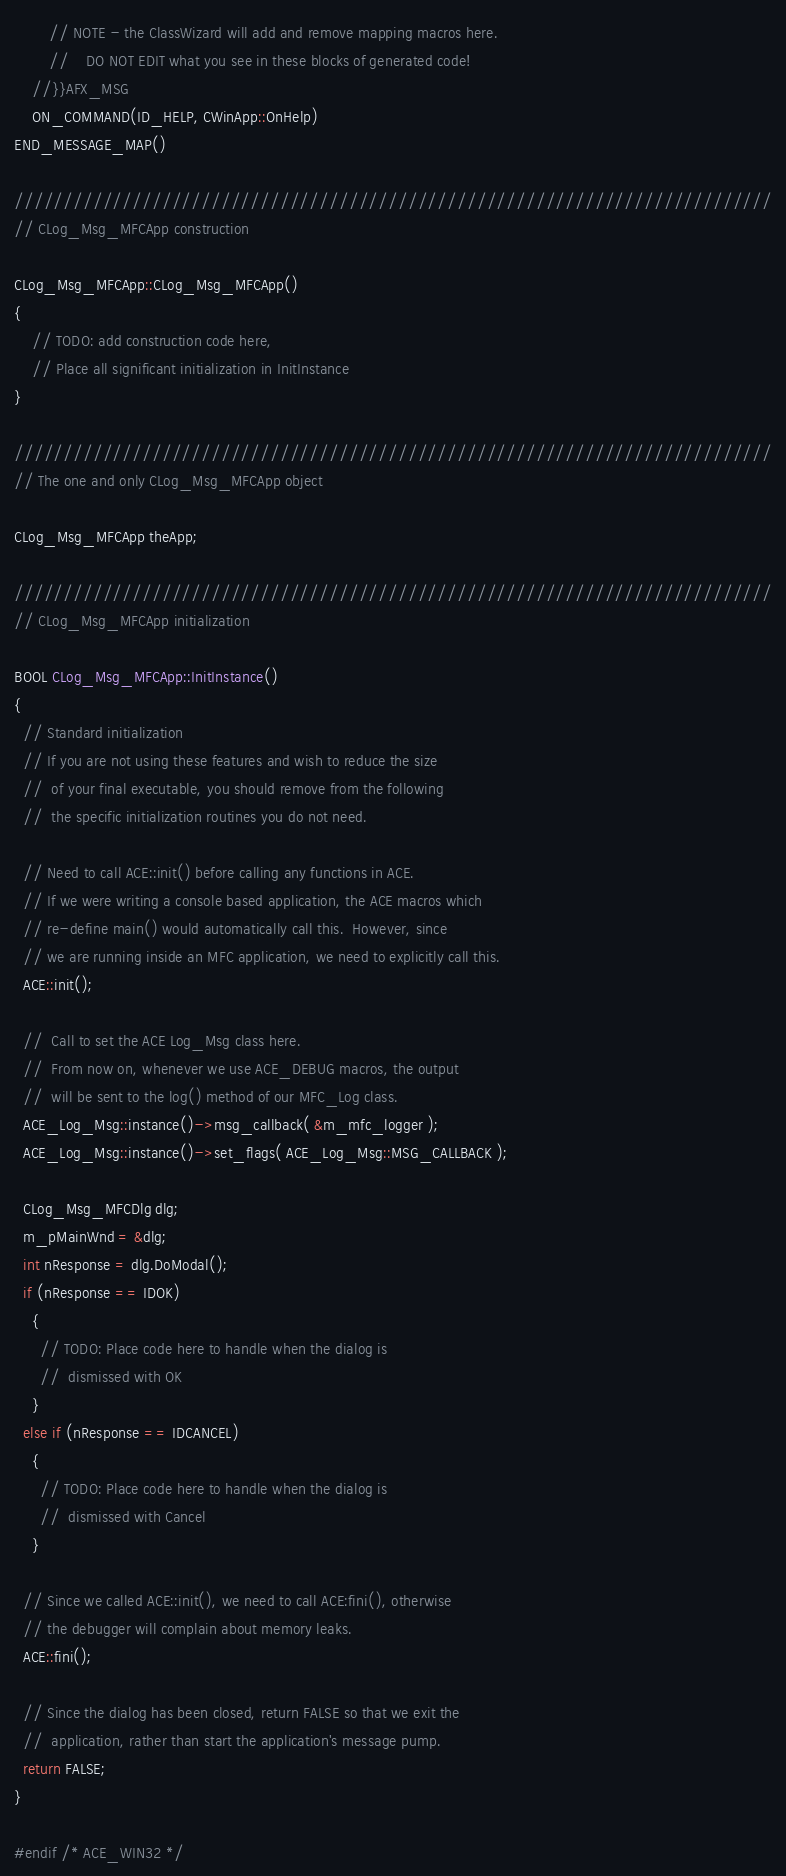<code> <loc_0><loc_0><loc_500><loc_500><_C++_>        // NOTE - the ClassWizard will add and remove mapping macros here.
        //    DO NOT EDIT what you see in these blocks of generated code!
    //}}AFX_MSG
    ON_COMMAND(ID_HELP, CWinApp::OnHelp)
END_MESSAGE_MAP()

/////////////////////////////////////////////////////////////////////////////
// CLog_Msg_MFCApp construction

CLog_Msg_MFCApp::CLog_Msg_MFCApp()
{
    // TODO: add construction code here,
    // Place all significant initialization in InitInstance
}

/////////////////////////////////////////////////////////////////////////////
// The one and only CLog_Msg_MFCApp object

CLog_Msg_MFCApp theApp;

/////////////////////////////////////////////////////////////////////////////
// CLog_Msg_MFCApp initialization

BOOL CLog_Msg_MFCApp::InitInstance()
{
  // Standard initialization
  // If you are not using these features and wish to reduce the size
  //  of your final executable, you should remove from the following
  //  the specific initialization routines you do not need.

  // Need to call ACE::init() before calling any functions in ACE.
  // If we were writing a console based application, the ACE macros which
  // re-define main() would automatically call this.  However, since
  // we are running inside an MFC application, we need to explicitly call this.
  ACE::init();

  //  Call to set the ACE Log_Msg class here.
  //  From now on, whenever we use ACE_DEBUG macros, the output
  //  will be sent to the log() method of our MFC_Log class.
  ACE_Log_Msg::instance()->msg_callback( &m_mfc_logger );
  ACE_Log_Msg::instance()->set_flags( ACE_Log_Msg::MSG_CALLBACK );

  CLog_Msg_MFCDlg dlg;
  m_pMainWnd = &dlg;
  int nResponse = dlg.DoModal();
  if (nResponse == IDOK)
    {
      // TODO: Place code here to handle when the dialog is
      //  dismissed with OK
    }
  else if (nResponse == IDCANCEL)
    {
      // TODO: Place code here to handle when the dialog is
      //  dismissed with Cancel
    }

  // Since we called ACE::init(), we need to call ACE:fini(), otherwise
  // the debugger will complain about memory leaks.
  ACE::fini();

  // Since the dialog has been closed, return FALSE so that we exit the
  //  application, rather than start the application's message pump.
  return FALSE;
}

#endif /* ACE_WIN32 */
</code> 